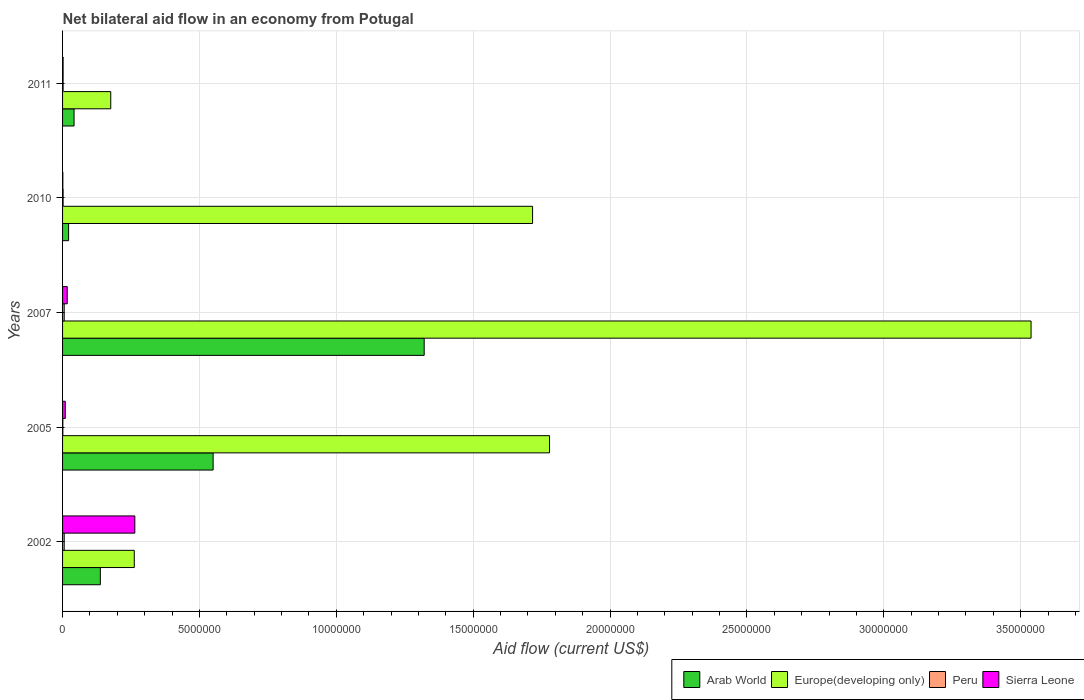How many groups of bars are there?
Give a very brief answer. 5. Are the number of bars per tick equal to the number of legend labels?
Provide a succinct answer. Yes. How many bars are there on the 1st tick from the top?
Keep it short and to the point. 4. In how many cases, is the number of bars for a given year not equal to the number of legend labels?
Offer a very short reply. 0. Across all years, what is the maximum net bilateral aid flow in Peru?
Give a very brief answer. 6.00e+04. Across all years, what is the minimum net bilateral aid flow in Arab World?
Ensure brevity in your answer.  2.20e+05. What is the total net bilateral aid flow in Sierra Leone in the graph?
Provide a short and direct response. 2.94e+06. What is the difference between the net bilateral aid flow in Europe(developing only) in 2011 and the net bilateral aid flow in Sierra Leone in 2002?
Offer a terse response. -8.80e+05. What is the average net bilateral aid flow in Peru per year?
Offer a very short reply. 3.40e+04. In the year 2002, what is the difference between the net bilateral aid flow in Arab World and net bilateral aid flow in Sierra Leone?
Your response must be concise. -1.26e+06. What is the ratio of the net bilateral aid flow in Sierra Leone in 2005 to that in 2007?
Offer a terse response. 0.59. What is the difference between the highest and the second highest net bilateral aid flow in Europe(developing only)?
Offer a very short reply. 1.76e+07. What is the difference between the highest and the lowest net bilateral aid flow in Peru?
Your response must be concise. 5.00e+04. What does the 3rd bar from the top in 2005 represents?
Offer a terse response. Europe(developing only). What does the 2nd bar from the bottom in 2007 represents?
Offer a terse response. Europe(developing only). Is it the case that in every year, the sum of the net bilateral aid flow in Peru and net bilateral aid flow in Sierra Leone is greater than the net bilateral aid flow in Europe(developing only)?
Your answer should be very brief. No. Are all the bars in the graph horizontal?
Make the answer very short. Yes. How many years are there in the graph?
Provide a short and direct response. 5. Where does the legend appear in the graph?
Your response must be concise. Bottom right. How many legend labels are there?
Give a very brief answer. 4. How are the legend labels stacked?
Provide a short and direct response. Horizontal. What is the title of the graph?
Your answer should be compact. Net bilateral aid flow in an economy from Potugal. Does "Zambia" appear as one of the legend labels in the graph?
Provide a short and direct response. No. What is the label or title of the X-axis?
Your answer should be very brief. Aid flow (current US$). What is the label or title of the Y-axis?
Provide a succinct answer. Years. What is the Aid flow (current US$) of Arab World in 2002?
Give a very brief answer. 1.38e+06. What is the Aid flow (current US$) in Europe(developing only) in 2002?
Your answer should be very brief. 2.62e+06. What is the Aid flow (current US$) in Peru in 2002?
Offer a very short reply. 6.00e+04. What is the Aid flow (current US$) of Sierra Leone in 2002?
Your answer should be compact. 2.64e+06. What is the Aid flow (current US$) in Arab World in 2005?
Provide a short and direct response. 5.50e+06. What is the Aid flow (current US$) in Europe(developing only) in 2005?
Make the answer very short. 1.78e+07. What is the Aid flow (current US$) in Peru in 2005?
Your response must be concise. 10000. What is the Aid flow (current US$) in Arab World in 2007?
Ensure brevity in your answer.  1.32e+07. What is the Aid flow (current US$) in Europe(developing only) in 2007?
Make the answer very short. 3.54e+07. What is the Aid flow (current US$) in Arab World in 2010?
Offer a very short reply. 2.20e+05. What is the Aid flow (current US$) of Europe(developing only) in 2010?
Keep it short and to the point. 1.72e+07. What is the Aid flow (current US$) of Peru in 2010?
Your answer should be very brief. 2.00e+04. What is the Aid flow (current US$) in Arab World in 2011?
Keep it short and to the point. 4.20e+05. What is the Aid flow (current US$) of Europe(developing only) in 2011?
Your answer should be very brief. 1.76e+06. What is the Aid flow (current US$) of Sierra Leone in 2011?
Give a very brief answer. 2.00e+04. Across all years, what is the maximum Aid flow (current US$) in Arab World?
Offer a very short reply. 1.32e+07. Across all years, what is the maximum Aid flow (current US$) in Europe(developing only)?
Your answer should be very brief. 3.54e+07. Across all years, what is the maximum Aid flow (current US$) in Peru?
Provide a short and direct response. 6.00e+04. Across all years, what is the maximum Aid flow (current US$) of Sierra Leone?
Offer a very short reply. 2.64e+06. Across all years, what is the minimum Aid flow (current US$) in Europe(developing only)?
Your answer should be very brief. 1.76e+06. What is the total Aid flow (current US$) in Arab World in the graph?
Provide a succinct answer. 2.07e+07. What is the total Aid flow (current US$) of Europe(developing only) in the graph?
Your answer should be very brief. 7.47e+07. What is the total Aid flow (current US$) of Peru in the graph?
Your answer should be compact. 1.70e+05. What is the total Aid flow (current US$) in Sierra Leone in the graph?
Give a very brief answer. 2.94e+06. What is the difference between the Aid flow (current US$) in Arab World in 2002 and that in 2005?
Make the answer very short. -4.12e+06. What is the difference between the Aid flow (current US$) of Europe(developing only) in 2002 and that in 2005?
Ensure brevity in your answer.  -1.52e+07. What is the difference between the Aid flow (current US$) in Peru in 2002 and that in 2005?
Keep it short and to the point. 5.00e+04. What is the difference between the Aid flow (current US$) in Sierra Leone in 2002 and that in 2005?
Offer a terse response. 2.54e+06. What is the difference between the Aid flow (current US$) in Arab World in 2002 and that in 2007?
Keep it short and to the point. -1.18e+07. What is the difference between the Aid flow (current US$) of Europe(developing only) in 2002 and that in 2007?
Your answer should be compact. -3.28e+07. What is the difference between the Aid flow (current US$) in Peru in 2002 and that in 2007?
Your answer should be very brief. 0. What is the difference between the Aid flow (current US$) in Sierra Leone in 2002 and that in 2007?
Provide a succinct answer. 2.47e+06. What is the difference between the Aid flow (current US$) of Arab World in 2002 and that in 2010?
Offer a terse response. 1.16e+06. What is the difference between the Aid flow (current US$) of Europe(developing only) in 2002 and that in 2010?
Make the answer very short. -1.46e+07. What is the difference between the Aid flow (current US$) of Peru in 2002 and that in 2010?
Provide a short and direct response. 4.00e+04. What is the difference between the Aid flow (current US$) in Sierra Leone in 2002 and that in 2010?
Offer a very short reply. 2.63e+06. What is the difference between the Aid flow (current US$) of Arab World in 2002 and that in 2011?
Your response must be concise. 9.60e+05. What is the difference between the Aid flow (current US$) in Europe(developing only) in 2002 and that in 2011?
Keep it short and to the point. 8.60e+05. What is the difference between the Aid flow (current US$) in Peru in 2002 and that in 2011?
Give a very brief answer. 4.00e+04. What is the difference between the Aid flow (current US$) of Sierra Leone in 2002 and that in 2011?
Your response must be concise. 2.62e+06. What is the difference between the Aid flow (current US$) of Arab World in 2005 and that in 2007?
Make the answer very short. -7.71e+06. What is the difference between the Aid flow (current US$) of Europe(developing only) in 2005 and that in 2007?
Keep it short and to the point. -1.76e+07. What is the difference between the Aid flow (current US$) in Arab World in 2005 and that in 2010?
Keep it short and to the point. 5.28e+06. What is the difference between the Aid flow (current US$) of Europe(developing only) in 2005 and that in 2010?
Give a very brief answer. 6.20e+05. What is the difference between the Aid flow (current US$) in Peru in 2005 and that in 2010?
Offer a terse response. -10000. What is the difference between the Aid flow (current US$) of Sierra Leone in 2005 and that in 2010?
Offer a very short reply. 9.00e+04. What is the difference between the Aid flow (current US$) in Arab World in 2005 and that in 2011?
Offer a very short reply. 5.08e+06. What is the difference between the Aid flow (current US$) in Europe(developing only) in 2005 and that in 2011?
Your answer should be very brief. 1.60e+07. What is the difference between the Aid flow (current US$) in Peru in 2005 and that in 2011?
Provide a succinct answer. -10000. What is the difference between the Aid flow (current US$) of Sierra Leone in 2005 and that in 2011?
Provide a short and direct response. 8.00e+04. What is the difference between the Aid flow (current US$) in Arab World in 2007 and that in 2010?
Your response must be concise. 1.30e+07. What is the difference between the Aid flow (current US$) in Europe(developing only) in 2007 and that in 2010?
Ensure brevity in your answer.  1.82e+07. What is the difference between the Aid flow (current US$) of Sierra Leone in 2007 and that in 2010?
Your answer should be compact. 1.60e+05. What is the difference between the Aid flow (current US$) in Arab World in 2007 and that in 2011?
Offer a very short reply. 1.28e+07. What is the difference between the Aid flow (current US$) in Europe(developing only) in 2007 and that in 2011?
Your response must be concise. 3.36e+07. What is the difference between the Aid flow (current US$) of Sierra Leone in 2007 and that in 2011?
Give a very brief answer. 1.50e+05. What is the difference between the Aid flow (current US$) of Arab World in 2010 and that in 2011?
Keep it short and to the point. -2.00e+05. What is the difference between the Aid flow (current US$) in Europe(developing only) in 2010 and that in 2011?
Offer a very short reply. 1.54e+07. What is the difference between the Aid flow (current US$) in Sierra Leone in 2010 and that in 2011?
Your answer should be compact. -10000. What is the difference between the Aid flow (current US$) of Arab World in 2002 and the Aid flow (current US$) of Europe(developing only) in 2005?
Ensure brevity in your answer.  -1.64e+07. What is the difference between the Aid flow (current US$) in Arab World in 2002 and the Aid flow (current US$) in Peru in 2005?
Provide a succinct answer. 1.37e+06. What is the difference between the Aid flow (current US$) of Arab World in 2002 and the Aid flow (current US$) of Sierra Leone in 2005?
Keep it short and to the point. 1.28e+06. What is the difference between the Aid flow (current US$) of Europe(developing only) in 2002 and the Aid flow (current US$) of Peru in 2005?
Provide a succinct answer. 2.61e+06. What is the difference between the Aid flow (current US$) in Europe(developing only) in 2002 and the Aid flow (current US$) in Sierra Leone in 2005?
Ensure brevity in your answer.  2.52e+06. What is the difference between the Aid flow (current US$) of Peru in 2002 and the Aid flow (current US$) of Sierra Leone in 2005?
Keep it short and to the point. -4.00e+04. What is the difference between the Aid flow (current US$) of Arab World in 2002 and the Aid flow (current US$) of Europe(developing only) in 2007?
Offer a very short reply. -3.40e+07. What is the difference between the Aid flow (current US$) of Arab World in 2002 and the Aid flow (current US$) of Peru in 2007?
Give a very brief answer. 1.32e+06. What is the difference between the Aid flow (current US$) in Arab World in 2002 and the Aid flow (current US$) in Sierra Leone in 2007?
Offer a very short reply. 1.21e+06. What is the difference between the Aid flow (current US$) in Europe(developing only) in 2002 and the Aid flow (current US$) in Peru in 2007?
Offer a terse response. 2.56e+06. What is the difference between the Aid flow (current US$) of Europe(developing only) in 2002 and the Aid flow (current US$) of Sierra Leone in 2007?
Give a very brief answer. 2.45e+06. What is the difference between the Aid flow (current US$) in Peru in 2002 and the Aid flow (current US$) in Sierra Leone in 2007?
Give a very brief answer. -1.10e+05. What is the difference between the Aid flow (current US$) in Arab World in 2002 and the Aid flow (current US$) in Europe(developing only) in 2010?
Provide a succinct answer. -1.58e+07. What is the difference between the Aid flow (current US$) in Arab World in 2002 and the Aid flow (current US$) in Peru in 2010?
Offer a terse response. 1.36e+06. What is the difference between the Aid flow (current US$) in Arab World in 2002 and the Aid flow (current US$) in Sierra Leone in 2010?
Your response must be concise. 1.37e+06. What is the difference between the Aid flow (current US$) in Europe(developing only) in 2002 and the Aid flow (current US$) in Peru in 2010?
Provide a succinct answer. 2.60e+06. What is the difference between the Aid flow (current US$) of Europe(developing only) in 2002 and the Aid flow (current US$) of Sierra Leone in 2010?
Offer a terse response. 2.61e+06. What is the difference between the Aid flow (current US$) in Peru in 2002 and the Aid flow (current US$) in Sierra Leone in 2010?
Provide a short and direct response. 5.00e+04. What is the difference between the Aid flow (current US$) of Arab World in 2002 and the Aid flow (current US$) of Europe(developing only) in 2011?
Provide a succinct answer. -3.80e+05. What is the difference between the Aid flow (current US$) in Arab World in 2002 and the Aid flow (current US$) in Peru in 2011?
Your answer should be compact. 1.36e+06. What is the difference between the Aid flow (current US$) in Arab World in 2002 and the Aid flow (current US$) in Sierra Leone in 2011?
Provide a succinct answer. 1.36e+06. What is the difference between the Aid flow (current US$) of Europe(developing only) in 2002 and the Aid flow (current US$) of Peru in 2011?
Your answer should be very brief. 2.60e+06. What is the difference between the Aid flow (current US$) in Europe(developing only) in 2002 and the Aid flow (current US$) in Sierra Leone in 2011?
Make the answer very short. 2.60e+06. What is the difference between the Aid flow (current US$) in Arab World in 2005 and the Aid flow (current US$) in Europe(developing only) in 2007?
Give a very brief answer. -2.99e+07. What is the difference between the Aid flow (current US$) of Arab World in 2005 and the Aid flow (current US$) of Peru in 2007?
Provide a short and direct response. 5.44e+06. What is the difference between the Aid flow (current US$) of Arab World in 2005 and the Aid flow (current US$) of Sierra Leone in 2007?
Provide a short and direct response. 5.33e+06. What is the difference between the Aid flow (current US$) of Europe(developing only) in 2005 and the Aid flow (current US$) of Peru in 2007?
Your response must be concise. 1.77e+07. What is the difference between the Aid flow (current US$) of Europe(developing only) in 2005 and the Aid flow (current US$) of Sierra Leone in 2007?
Your response must be concise. 1.76e+07. What is the difference between the Aid flow (current US$) of Peru in 2005 and the Aid flow (current US$) of Sierra Leone in 2007?
Ensure brevity in your answer.  -1.60e+05. What is the difference between the Aid flow (current US$) in Arab World in 2005 and the Aid flow (current US$) in Europe(developing only) in 2010?
Your answer should be compact. -1.17e+07. What is the difference between the Aid flow (current US$) of Arab World in 2005 and the Aid flow (current US$) of Peru in 2010?
Provide a short and direct response. 5.48e+06. What is the difference between the Aid flow (current US$) in Arab World in 2005 and the Aid flow (current US$) in Sierra Leone in 2010?
Provide a short and direct response. 5.49e+06. What is the difference between the Aid flow (current US$) in Europe(developing only) in 2005 and the Aid flow (current US$) in Peru in 2010?
Ensure brevity in your answer.  1.78e+07. What is the difference between the Aid flow (current US$) of Europe(developing only) in 2005 and the Aid flow (current US$) of Sierra Leone in 2010?
Offer a very short reply. 1.78e+07. What is the difference between the Aid flow (current US$) in Peru in 2005 and the Aid flow (current US$) in Sierra Leone in 2010?
Ensure brevity in your answer.  0. What is the difference between the Aid flow (current US$) of Arab World in 2005 and the Aid flow (current US$) of Europe(developing only) in 2011?
Provide a short and direct response. 3.74e+06. What is the difference between the Aid flow (current US$) of Arab World in 2005 and the Aid flow (current US$) of Peru in 2011?
Provide a short and direct response. 5.48e+06. What is the difference between the Aid flow (current US$) in Arab World in 2005 and the Aid flow (current US$) in Sierra Leone in 2011?
Make the answer very short. 5.48e+06. What is the difference between the Aid flow (current US$) of Europe(developing only) in 2005 and the Aid flow (current US$) of Peru in 2011?
Offer a terse response. 1.78e+07. What is the difference between the Aid flow (current US$) in Europe(developing only) in 2005 and the Aid flow (current US$) in Sierra Leone in 2011?
Ensure brevity in your answer.  1.78e+07. What is the difference between the Aid flow (current US$) in Peru in 2005 and the Aid flow (current US$) in Sierra Leone in 2011?
Make the answer very short. -10000. What is the difference between the Aid flow (current US$) in Arab World in 2007 and the Aid flow (current US$) in Europe(developing only) in 2010?
Keep it short and to the point. -3.96e+06. What is the difference between the Aid flow (current US$) of Arab World in 2007 and the Aid flow (current US$) of Peru in 2010?
Your answer should be very brief. 1.32e+07. What is the difference between the Aid flow (current US$) of Arab World in 2007 and the Aid flow (current US$) of Sierra Leone in 2010?
Your answer should be compact. 1.32e+07. What is the difference between the Aid flow (current US$) of Europe(developing only) in 2007 and the Aid flow (current US$) of Peru in 2010?
Your answer should be very brief. 3.54e+07. What is the difference between the Aid flow (current US$) in Europe(developing only) in 2007 and the Aid flow (current US$) in Sierra Leone in 2010?
Offer a terse response. 3.54e+07. What is the difference between the Aid flow (current US$) in Arab World in 2007 and the Aid flow (current US$) in Europe(developing only) in 2011?
Make the answer very short. 1.14e+07. What is the difference between the Aid flow (current US$) of Arab World in 2007 and the Aid flow (current US$) of Peru in 2011?
Make the answer very short. 1.32e+07. What is the difference between the Aid flow (current US$) of Arab World in 2007 and the Aid flow (current US$) of Sierra Leone in 2011?
Ensure brevity in your answer.  1.32e+07. What is the difference between the Aid flow (current US$) in Europe(developing only) in 2007 and the Aid flow (current US$) in Peru in 2011?
Offer a very short reply. 3.54e+07. What is the difference between the Aid flow (current US$) in Europe(developing only) in 2007 and the Aid flow (current US$) in Sierra Leone in 2011?
Your answer should be compact. 3.54e+07. What is the difference between the Aid flow (current US$) of Arab World in 2010 and the Aid flow (current US$) of Europe(developing only) in 2011?
Make the answer very short. -1.54e+06. What is the difference between the Aid flow (current US$) of Europe(developing only) in 2010 and the Aid flow (current US$) of Peru in 2011?
Provide a succinct answer. 1.72e+07. What is the difference between the Aid flow (current US$) of Europe(developing only) in 2010 and the Aid flow (current US$) of Sierra Leone in 2011?
Make the answer very short. 1.72e+07. What is the difference between the Aid flow (current US$) of Peru in 2010 and the Aid flow (current US$) of Sierra Leone in 2011?
Make the answer very short. 0. What is the average Aid flow (current US$) of Arab World per year?
Your response must be concise. 4.15e+06. What is the average Aid flow (current US$) of Europe(developing only) per year?
Make the answer very short. 1.49e+07. What is the average Aid flow (current US$) in Peru per year?
Ensure brevity in your answer.  3.40e+04. What is the average Aid flow (current US$) in Sierra Leone per year?
Provide a succinct answer. 5.88e+05. In the year 2002, what is the difference between the Aid flow (current US$) in Arab World and Aid flow (current US$) in Europe(developing only)?
Give a very brief answer. -1.24e+06. In the year 2002, what is the difference between the Aid flow (current US$) in Arab World and Aid flow (current US$) in Peru?
Make the answer very short. 1.32e+06. In the year 2002, what is the difference between the Aid flow (current US$) of Arab World and Aid flow (current US$) of Sierra Leone?
Give a very brief answer. -1.26e+06. In the year 2002, what is the difference between the Aid flow (current US$) in Europe(developing only) and Aid flow (current US$) in Peru?
Keep it short and to the point. 2.56e+06. In the year 2002, what is the difference between the Aid flow (current US$) of Peru and Aid flow (current US$) of Sierra Leone?
Make the answer very short. -2.58e+06. In the year 2005, what is the difference between the Aid flow (current US$) of Arab World and Aid flow (current US$) of Europe(developing only)?
Provide a succinct answer. -1.23e+07. In the year 2005, what is the difference between the Aid flow (current US$) of Arab World and Aid flow (current US$) of Peru?
Provide a short and direct response. 5.49e+06. In the year 2005, what is the difference between the Aid flow (current US$) of Arab World and Aid flow (current US$) of Sierra Leone?
Your response must be concise. 5.40e+06. In the year 2005, what is the difference between the Aid flow (current US$) of Europe(developing only) and Aid flow (current US$) of Peru?
Your answer should be very brief. 1.78e+07. In the year 2005, what is the difference between the Aid flow (current US$) in Europe(developing only) and Aid flow (current US$) in Sierra Leone?
Your response must be concise. 1.77e+07. In the year 2007, what is the difference between the Aid flow (current US$) in Arab World and Aid flow (current US$) in Europe(developing only)?
Ensure brevity in your answer.  -2.22e+07. In the year 2007, what is the difference between the Aid flow (current US$) of Arab World and Aid flow (current US$) of Peru?
Provide a short and direct response. 1.32e+07. In the year 2007, what is the difference between the Aid flow (current US$) in Arab World and Aid flow (current US$) in Sierra Leone?
Make the answer very short. 1.30e+07. In the year 2007, what is the difference between the Aid flow (current US$) in Europe(developing only) and Aid flow (current US$) in Peru?
Give a very brief answer. 3.53e+07. In the year 2007, what is the difference between the Aid flow (current US$) in Europe(developing only) and Aid flow (current US$) in Sierra Leone?
Provide a succinct answer. 3.52e+07. In the year 2007, what is the difference between the Aid flow (current US$) of Peru and Aid flow (current US$) of Sierra Leone?
Keep it short and to the point. -1.10e+05. In the year 2010, what is the difference between the Aid flow (current US$) in Arab World and Aid flow (current US$) in Europe(developing only)?
Provide a succinct answer. -1.70e+07. In the year 2010, what is the difference between the Aid flow (current US$) of Arab World and Aid flow (current US$) of Sierra Leone?
Offer a very short reply. 2.10e+05. In the year 2010, what is the difference between the Aid flow (current US$) of Europe(developing only) and Aid flow (current US$) of Peru?
Offer a terse response. 1.72e+07. In the year 2010, what is the difference between the Aid flow (current US$) of Europe(developing only) and Aid flow (current US$) of Sierra Leone?
Keep it short and to the point. 1.72e+07. In the year 2011, what is the difference between the Aid flow (current US$) of Arab World and Aid flow (current US$) of Europe(developing only)?
Keep it short and to the point. -1.34e+06. In the year 2011, what is the difference between the Aid flow (current US$) of Arab World and Aid flow (current US$) of Sierra Leone?
Give a very brief answer. 4.00e+05. In the year 2011, what is the difference between the Aid flow (current US$) in Europe(developing only) and Aid flow (current US$) in Peru?
Your answer should be very brief. 1.74e+06. In the year 2011, what is the difference between the Aid flow (current US$) in Europe(developing only) and Aid flow (current US$) in Sierra Leone?
Provide a succinct answer. 1.74e+06. In the year 2011, what is the difference between the Aid flow (current US$) in Peru and Aid flow (current US$) in Sierra Leone?
Your answer should be very brief. 0. What is the ratio of the Aid flow (current US$) in Arab World in 2002 to that in 2005?
Your response must be concise. 0.25. What is the ratio of the Aid flow (current US$) in Europe(developing only) in 2002 to that in 2005?
Ensure brevity in your answer.  0.15. What is the ratio of the Aid flow (current US$) in Peru in 2002 to that in 2005?
Provide a short and direct response. 6. What is the ratio of the Aid flow (current US$) of Sierra Leone in 2002 to that in 2005?
Offer a very short reply. 26.4. What is the ratio of the Aid flow (current US$) of Arab World in 2002 to that in 2007?
Keep it short and to the point. 0.1. What is the ratio of the Aid flow (current US$) in Europe(developing only) in 2002 to that in 2007?
Provide a succinct answer. 0.07. What is the ratio of the Aid flow (current US$) of Sierra Leone in 2002 to that in 2007?
Make the answer very short. 15.53. What is the ratio of the Aid flow (current US$) in Arab World in 2002 to that in 2010?
Make the answer very short. 6.27. What is the ratio of the Aid flow (current US$) of Europe(developing only) in 2002 to that in 2010?
Make the answer very short. 0.15. What is the ratio of the Aid flow (current US$) of Sierra Leone in 2002 to that in 2010?
Your answer should be very brief. 264. What is the ratio of the Aid flow (current US$) of Arab World in 2002 to that in 2011?
Keep it short and to the point. 3.29. What is the ratio of the Aid flow (current US$) in Europe(developing only) in 2002 to that in 2011?
Your answer should be very brief. 1.49. What is the ratio of the Aid flow (current US$) of Sierra Leone in 2002 to that in 2011?
Offer a terse response. 132. What is the ratio of the Aid flow (current US$) in Arab World in 2005 to that in 2007?
Provide a short and direct response. 0.42. What is the ratio of the Aid flow (current US$) in Europe(developing only) in 2005 to that in 2007?
Keep it short and to the point. 0.5. What is the ratio of the Aid flow (current US$) in Peru in 2005 to that in 2007?
Make the answer very short. 0.17. What is the ratio of the Aid flow (current US$) in Sierra Leone in 2005 to that in 2007?
Your answer should be very brief. 0.59. What is the ratio of the Aid flow (current US$) of Europe(developing only) in 2005 to that in 2010?
Provide a short and direct response. 1.04. What is the ratio of the Aid flow (current US$) of Arab World in 2005 to that in 2011?
Your response must be concise. 13.1. What is the ratio of the Aid flow (current US$) of Europe(developing only) in 2005 to that in 2011?
Your answer should be compact. 10.11. What is the ratio of the Aid flow (current US$) of Peru in 2005 to that in 2011?
Offer a terse response. 0.5. What is the ratio of the Aid flow (current US$) in Sierra Leone in 2005 to that in 2011?
Provide a short and direct response. 5. What is the ratio of the Aid flow (current US$) in Arab World in 2007 to that in 2010?
Provide a short and direct response. 60.05. What is the ratio of the Aid flow (current US$) of Europe(developing only) in 2007 to that in 2010?
Make the answer very short. 2.06. What is the ratio of the Aid flow (current US$) of Arab World in 2007 to that in 2011?
Ensure brevity in your answer.  31.45. What is the ratio of the Aid flow (current US$) in Europe(developing only) in 2007 to that in 2011?
Offer a very short reply. 20.1. What is the ratio of the Aid flow (current US$) of Peru in 2007 to that in 2011?
Your answer should be compact. 3. What is the ratio of the Aid flow (current US$) of Sierra Leone in 2007 to that in 2011?
Provide a short and direct response. 8.5. What is the ratio of the Aid flow (current US$) in Arab World in 2010 to that in 2011?
Provide a short and direct response. 0.52. What is the ratio of the Aid flow (current US$) in Europe(developing only) in 2010 to that in 2011?
Ensure brevity in your answer.  9.76. What is the ratio of the Aid flow (current US$) of Peru in 2010 to that in 2011?
Your response must be concise. 1. What is the ratio of the Aid flow (current US$) of Sierra Leone in 2010 to that in 2011?
Provide a short and direct response. 0.5. What is the difference between the highest and the second highest Aid flow (current US$) of Arab World?
Keep it short and to the point. 7.71e+06. What is the difference between the highest and the second highest Aid flow (current US$) in Europe(developing only)?
Offer a very short reply. 1.76e+07. What is the difference between the highest and the second highest Aid flow (current US$) of Sierra Leone?
Your response must be concise. 2.47e+06. What is the difference between the highest and the lowest Aid flow (current US$) of Arab World?
Ensure brevity in your answer.  1.30e+07. What is the difference between the highest and the lowest Aid flow (current US$) in Europe(developing only)?
Provide a short and direct response. 3.36e+07. What is the difference between the highest and the lowest Aid flow (current US$) in Sierra Leone?
Your response must be concise. 2.63e+06. 